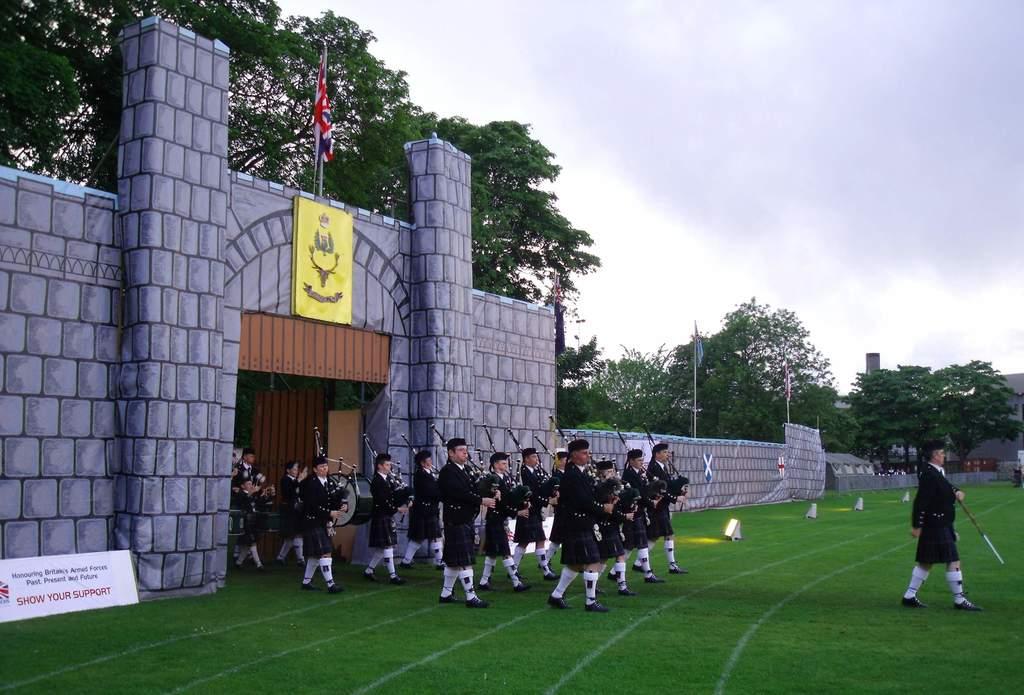What is the text on the white board?
Keep it short and to the point. Show your support. Show your what?
Make the answer very short. Support. 